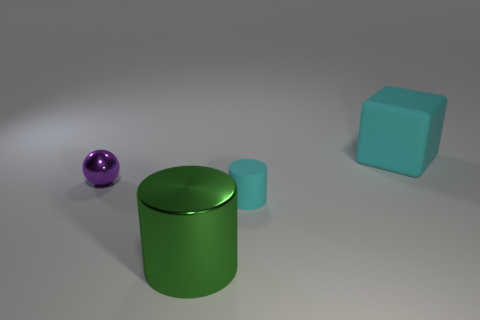Add 1 rubber cylinders. How many objects exist? 5 Subtract all spheres. How many objects are left? 3 Subtract all brown cubes. How many red spheres are left? 0 Subtract all cylinders. Subtract all purple objects. How many objects are left? 1 Add 1 blocks. How many blocks are left? 2 Add 1 tiny blocks. How many tiny blocks exist? 1 Subtract all green cylinders. How many cylinders are left? 1 Subtract 0 yellow cubes. How many objects are left? 4 Subtract 1 cylinders. How many cylinders are left? 1 Subtract all red cylinders. Subtract all brown blocks. How many cylinders are left? 2 